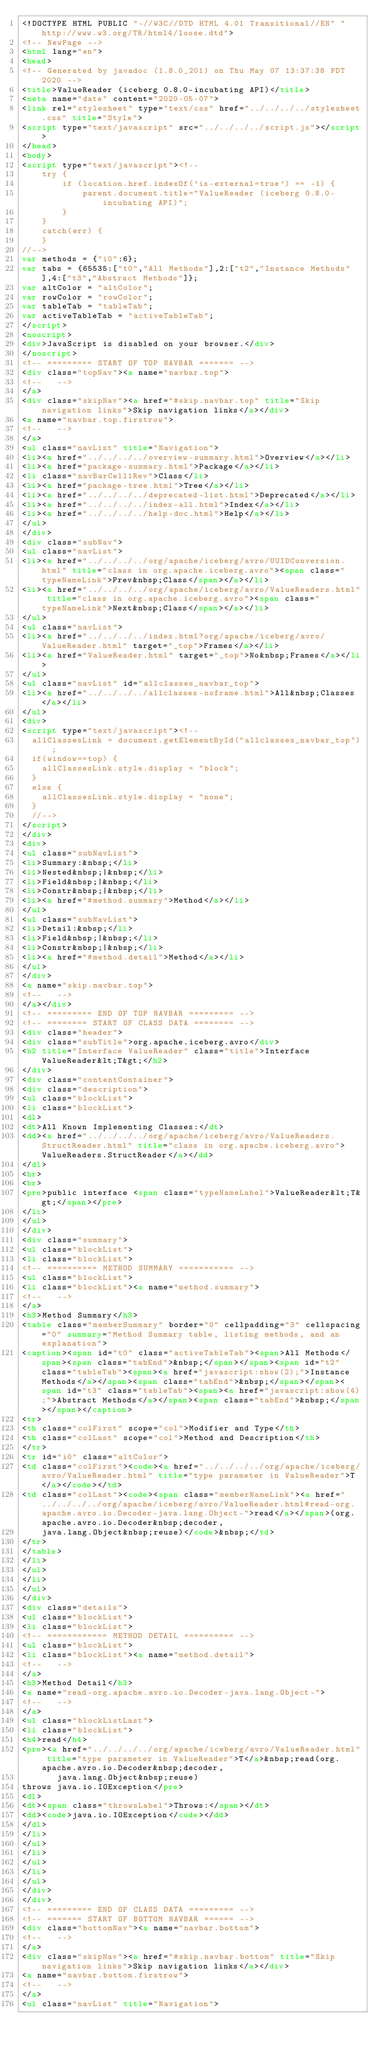Convert code to text. <code><loc_0><loc_0><loc_500><loc_500><_HTML_><!DOCTYPE HTML PUBLIC "-//W3C//DTD HTML 4.01 Transitional//EN" "http://www.w3.org/TR/html4/loose.dtd">
<!-- NewPage -->
<html lang="en">
<head>
<!-- Generated by javadoc (1.8.0_201) on Thu May 07 13:37:38 PDT 2020 -->
<title>ValueReader (iceberg 0.8.0-incubating API)</title>
<meta name="date" content="2020-05-07">
<link rel="stylesheet" type="text/css" href="../../../../stylesheet.css" title="Style">
<script type="text/javascript" src="../../../../script.js"></script>
</head>
<body>
<script type="text/javascript"><!--
    try {
        if (location.href.indexOf('is-external=true') == -1) {
            parent.document.title="ValueReader (iceberg 0.8.0-incubating API)";
        }
    }
    catch(err) {
    }
//-->
var methods = {"i0":6};
var tabs = {65535:["t0","All Methods"],2:["t2","Instance Methods"],4:["t3","Abstract Methods"]};
var altColor = "altColor";
var rowColor = "rowColor";
var tableTab = "tableTab";
var activeTableTab = "activeTableTab";
</script>
<noscript>
<div>JavaScript is disabled on your browser.</div>
</noscript>
<!-- ========= START OF TOP NAVBAR ======= -->
<div class="topNav"><a name="navbar.top">
<!--   -->
</a>
<div class="skipNav"><a href="#skip.navbar.top" title="Skip navigation links">Skip navigation links</a></div>
<a name="navbar.top.firstrow">
<!--   -->
</a>
<ul class="navList" title="Navigation">
<li><a href="../../../../overview-summary.html">Overview</a></li>
<li><a href="package-summary.html">Package</a></li>
<li class="navBarCell1Rev">Class</li>
<li><a href="package-tree.html">Tree</a></li>
<li><a href="../../../../deprecated-list.html">Deprecated</a></li>
<li><a href="../../../../index-all.html">Index</a></li>
<li><a href="../../../../help-doc.html">Help</a></li>
</ul>
</div>
<div class="subNav">
<ul class="navList">
<li><a href="../../../../org/apache/iceberg/avro/UUIDConversion.html" title="class in org.apache.iceberg.avro"><span class="typeNameLink">Prev&nbsp;Class</span></a></li>
<li><a href="../../../../org/apache/iceberg/avro/ValueReaders.html" title="class in org.apache.iceberg.avro"><span class="typeNameLink">Next&nbsp;Class</span></a></li>
</ul>
<ul class="navList">
<li><a href="../../../../index.html?org/apache/iceberg/avro/ValueReader.html" target="_top">Frames</a></li>
<li><a href="ValueReader.html" target="_top">No&nbsp;Frames</a></li>
</ul>
<ul class="navList" id="allclasses_navbar_top">
<li><a href="../../../../allclasses-noframe.html">All&nbsp;Classes</a></li>
</ul>
<div>
<script type="text/javascript"><!--
  allClassesLink = document.getElementById("allclasses_navbar_top");
  if(window==top) {
    allClassesLink.style.display = "block";
  }
  else {
    allClassesLink.style.display = "none";
  }
  //-->
</script>
</div>
<div>
<ul class="subNavList">
<li>Summary:&nbsp;</li>
<li>Nested&nbsp;|&nbsp;</li>
<li>Field&nbsp;|&nbsp;</li>
<li>Constr&nbsp;|&nbsp;</li>
<li><a href="#method.summary">Method</a></li>
</ul>
<ul class="subNavList">
<li>Detail:&nbsp;</li>
<li>Field&nbsp;|&nbsp;</li>
<li>Constr&nbsp;|&nbsp;</li>
<li><a href="#method.detail">Method</a></li>
</ul>
</div>
<a name="skip.navbar.top">
<!--   -->
</a></div>
<!-- ========= END OF TOP NAVBAR ========= -->
<!-- ======== START OF CLASS DATA ======== -->
<div class="header">
<div class="subTitle">org.apache.iceberg.avro</div>
<h2 title="Interface ValueReader" class="title">Interface ValueReader&lt;T&gt;</h2>
</div>
<div class="contentContainer">
<div class="description">
<ul class="blockList">
<li class="blockList">
<dl>
<dt>All Known Implementing Classes:</dt>
<dd><a href="../../../../org/apache/iceberg/avro/ValueReaders.StructReader.html" title="class in org.apache.iceberg.avro">ValueReaders.StructReader</a></dd>
</dl>
<hr>
<br>
<pre>public interface <span class="typeNameLabel">ValueReader&lt;T&gt;</span></pre>
</li>
</ul>
</div>
<div class="summary">
<ul class="blockList">
<li class="blockList">
<!-- ========== METHOD SUMMARY =========== -->
<ul class="blockList">
<li class="blockList"><a name="method.summary">
<!--   -->
</a>
<h3>Method Summary</h3>
<table class="memberSummary" border="0" cellpadding="3" cellspacing="0" summary="Method Summary table, listing methods, and an explanation">
<caption><span id="t0" class="activeTableTab"><span>All Methods</span><span class="tabEnd">&nbsp;</span></span><span id="t2" class="tableTab"><span><a href="javascript:show(2);">Instance Methods</a></span><span class="tabEnd">&nbsp;</span></span><span id="t3" class="tableTab"><span><a href="javascript:show(4);">Abstract Methods</a></span><span class="tabEnd">&nbsp;</span></span></caption>
<tr>
<th class="colFirst" scope="col">Modifier and Type</th>
<th class="colLast" scope="col">Method and Description</th>
</tr>
<tr id="i0" class="altColor">
<td class="colFirst"><code><a href="../../../../org/apache/iceberg/avro/ValueReader.html" title="type parameter in ValueReader">T</a></code></td>
<td class="colLast"><code><span class="memberNameLink"><a href="../../../../org/apache/iceberg/avro/ValueReader.html#read-org.apache.avro.io.Decoder-java.lang.Object-">read</a></span>(org.apache.avro.io.Decoder&nbsp;decoder,
    java.lang.Object&nbsp;reuse)</code>&nbsp;</td>
</tr>
</table>
</li>
</ul>
</li>
</ul>
</div>
<div class="details">
<ul class="blockList">
<li class="blockList">
<!-- ============ METHOD DETAIL ========== -->
<ul class="blockList">
<li class="blockList"><a name="method.detail">
<!--   -->
</a>
<h3>Method Detail</h3>
<a name="read-org.apache.avro.io.Decoder-java.lang.Object-">
<!--   -->
</a>
<ul class="blockListLast">
<li class="blockList">
<h4>read</h4>
<pre><a href="../../../../org/apache/iceberg/avro/ValueReader.html" title="type parameter in ValueReader">T</a>&nbsp;read(org.apache.avro.io.Decoder&nbsp;decoder,
       java.lang.Object&nbsp;reuse)
throws java.io.IOException</pre>
<dl>
<dt><span class="throwsLabel">Throws:</span></dt>
<dd><code>java.io.IOException</code></dd>
</dl>
</li>
</ul>
</li>
</ul>
</li>
</ul>
</div>
</div>
<!-- ========= END OF CLASS DATA ========= -->
<!-- ======= START OF BOTTOM NAVBAR ====== -->
<div class="bottomNav"><a name="navbar.bottom">
<!--   -->
</a>
<div class="skipNav"><a href="#skip.navbar.bottom" title="Skip navigation links">Skip navigation links</a></div>
<a name="navbar.bottom.firstrow">
<!--   -->
</a>
<ul class="navList" title="Navigation"></code> 